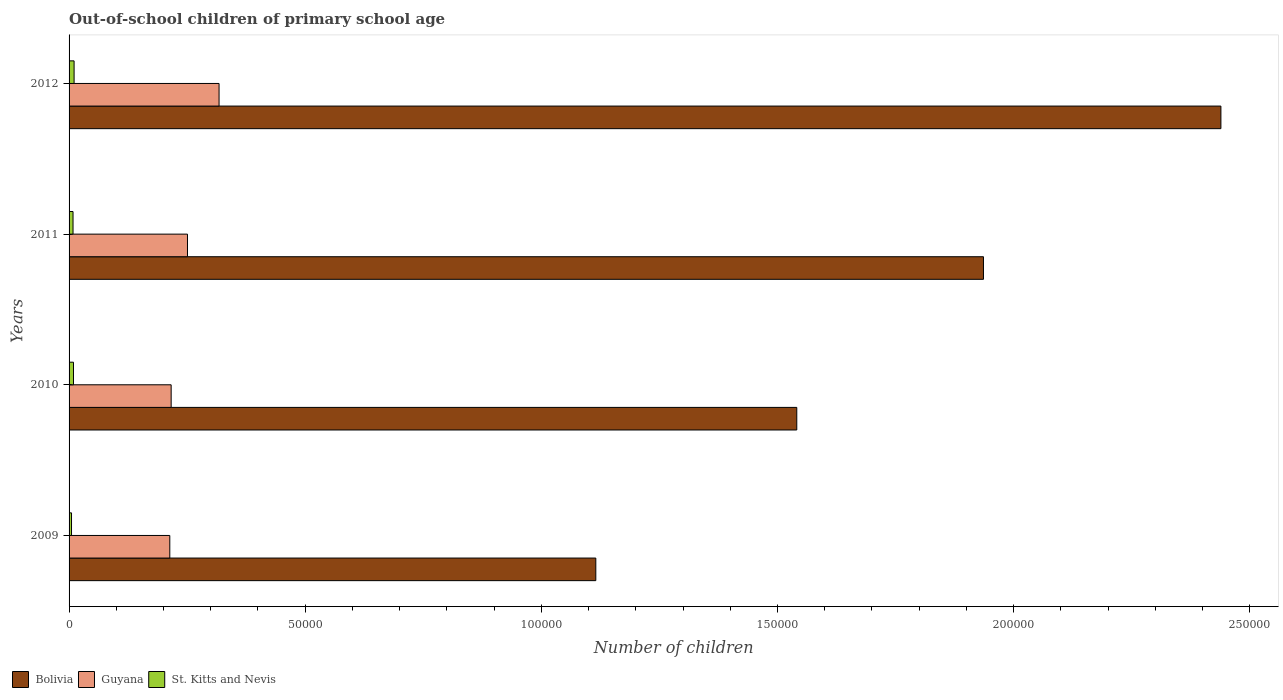How many different coloured bars are there?
Your answer should be very brief. 3. How many groups of bars are there?
Provide a short and direct response. 4. Are the number of bars per tick equal to the number of legend labels?
Your answer should be very brief. Yes. Are the number of bars on each tick of the Y-axis equal?
Offer a very short reply. Yes. How many bars are there on the 4th tick from the top?
Your answer should be very brief. 3. What is the number of out-of-school children in Bolivia in 2012?
Offer a very short reply. 2.44e+05. Across all years, what is the maximum number of out-of-school children in Guyana?
Give a very brief answer. 3.18e+04. Across all years, what is the minimum number of out-of-school children in Bolivia?
Your response must be concise. 1.12e+05. In which year was the number of out-of-school children in Guyana maximum?
Provide a short and direct response. 2012. In which year was the number of out-of-school children in Bolivia minimum?
Keep it short and to the point. 2009. What is the total number of out-of-school children in St. Kitts and Nevis in the graph?
Keep it short and to the point. 3354. What is the difference between the number of out-of-school children in Bolivia in 2011 and that in 2012?
Your answer should be compact. -5.03e+04. What is the difference between the number of out-of-school children in Bolivia in 2010 and the number of out-of-school children in St. Kitts and Nevis in 2009?
Your answer should be compact. 1.54e+05. What is the average number of out-of-school children in St. Kitts and Nevis per year?
Your response must be concise. 838.5. In the year 2011, what is the difference between the number of out-of-school children in Guyana and number of out-of-school children in St. Kitts and Nevis?
Offer a very short reply. 2.42e+04. What is the ratio of the number of out-of-school children in St. Kitts and Nevis in 2009 to that in 2012?
Your answer should be compact. 0.49. Is the number of out-of-school children in Guyana in 2009 less than that in 2011?
Ensure brevity in your answer.  Yes. Is the difference between the number of out-of-school children in Guyana in 2010 and 2011 greater than the difference between the number of out-of-school children in St. Kitts and Nevis in 2010 and 2011?
Make the answer very short. No. What is the difference between the highest and the second highest number of out-of-school children in Bolivia?
Your answer should be compact. 5.03e+04. What is the difference between the highest and the lowest number of out-of-school children in Bolivia?
Provide a short and direct response. 1.32e+05. Is the sum of the number of out-of-school children in Bolivia in 2010 and 2011 greater than the maximum number of out-of-school children in Guyana across all years?
Ensure brevity in your answer.  Yes. What does the 3rd bar from the top in 2010 represents?
Provide a succinct answer. Bolivia. What does the 2nd bar from the bottom in 2011 represents?
Keep it short and to the point. Guyana. How many bars are there?
Provide a short and direct response. 12. How many years are there in the graph?
Ensure brevity in your answer.  4. Does the graph contain any zero values?
Keep it short and to the point. No. How many legend labels are there?
Your answer should be compact. 3. What is the title of the graph?
Provide a short and direct response. Out-of-school children of primary school age. Does "Papua New Guinea" appear as one of the legend labels in the graph?
Keep it short and to the point. No. What is the label or title of the X-axis?
Offer a very short reply. Number of children. What is the Number of children of Bolivia in 2009?
Your answer should be very brief. 1.12e+05. What is the Number of children of Guyana in 2009?
Your response must be concise. 2.13e+04. What is the Number of children of St. Kitts and Nevis in 2009?
Offer a very short reply. 518. What is the Number of children in Bolivia in 2010?
Keep it short and to the point. 1.54e+05. What is the Number of children of Guyana in 2010?
Provide a succinct answer. 2.16e+04. What is the Number of children in St. Kitts and Nevis in 2010?
Keep it short and to the point. 936. What is the Number of children in Bolivia in 2011?
Offer a terse response. 1.94e+05. What is the Number of children of Guyana in 2011?
Offer a terse response. 2.51e+04. What is the Number of children in St. Kitts and Nevis in 2011?
Give a very brief answer. 838. What is the Number of children in Bolivia in 2012?
Provide a succinct answer. 2.44e+05. What is the Number of children in Guyana in 2012?
Provide a succinct answer. 3.18e+04. What is the Number of children in St. Kitts and Nevis in 2012?
Offer a terse response. 1062. Across all years, what is the maximum Number of children in Bolivia?
Your answer should be compact. 2.44e+05. Across all years, what is the maximum Number of children in Guyana?
Your response must be concise. 3.18e+04. Across all years, what is the maximum Number of children of St. Kitts and Nevis?
Ensure brevity in your answer.  1062. Across all years, what is the minimum Number of children of Bolivia?
Offer a terse response. 1.12e+05. Across all years, what is the minimum Number of children of Guyana?
Ensure brevity in your answer.  2.13e+04. Across all years, what is the minimum Number of children in St. Kitts and Nevis?
Offer a terse response. 518. What is the total Number of children in Bolivia in the graph?
Offer a very short reply. 7.03e+05. What is the total Number of children of Guyana in the graph?
Your answer should be compact. 9.98e+04. What is the total Number of children in St. Kitts and Nevis in the graph?
Your answer should be very brief. 3354. What is the difference between the Number of children in Bolivia in 2009 and that in 2010?
Provide a short and direct response. -4.26e+04. What is the difference between the Number of children in Guyana in 2009 and that in 2010?
Your response must be concise. -288. What is the difference between the Number of children in St. Kitts and Nevis in 2009 and that in 2010?
Your response must be concise. -418. What is the difference between the Number of children in Bolivia in 2009 and that in 2011?
Offer a terse response. -8.21e+04. What is the difference between the Number of children in Guyana in 2009 and that in 2011?
Provide a succinct answer. -3745. What is the difference between the Number of children in St. Kitts and Nevis in 2009 and that in 2011?
Offer a very short reply. -320. What is the difference between the Number of children in Bolivia in 2009 and that in 2012?
Your answer should be compact. -1.32e+05. What is the difference between the Number of children in Guyana in 2009 and that in 2012?
Provide a succinct answer. -1.04e+04. What is the difference between the Number of children in St. Kitts and Nevis in 2009 and that in 2012?
Ensure brevity in your answer.  -544. What is the difference between the Number of children in Bolivia in 2010 and that in 2011?
Make the answer very short. -3.95e+04. What is the difference between the Number of children of Guyana in 2010 and that in 2011?
Provide a short and direct response. -3457. What is the difference between the Number of children of Bolivia in 2010 and that in 2012?
Keep it short and to the point. -8.98e+04. What is the difference between the Number of children in Guyana in 2010 and that in 2012?
Offer a very short reply. -1.01e+04. What is the difference between the Number of children in St. Kitts and Nevis in 2010 and that in 2012?
Your answer should be very brief. -126. What is the difference between the Number of children in Bolivia in 2011 and that in 2012?
Your answer should be very brief. -5.03e+04. What is the difference between the Number of children in Guyana in 2011 and that in 2012?
Provide a short and direct response. -6688. What is the difference between the Number of children in St. Kitts and Nevis in 2011 and that in 2012?
Provide a succinct answer. -224. What is the difference between the Number of children of Bolivia in 2009 and the Number of children of Guyana in 2010?
Offer a very short reply. 8.99e+04. What is the difference between the Number of children of Bolivia in 2009 and the Number of children of St. Kitts and Nevis in 2010?
Give a very brief answer. 1.11e+05. What is the difference between the Number of children in Guyana in 2009 and the Number of children in St. Kitts and Nevis in 2010?
Make the answer very short. 2.04e+04. What is the difference between the Number of children in Bolivia in 2009 and the Number of children in Guyana in 2011?
Provide a short and direct response. 8.65e+04. What is the difference between the Number of children in Bolivia in 2009 and the Number of children in St. Kitts and Nevis in 2011?
Provide a succinct answer. 1.11e+05. What is the difference between the Number of children of Guyana in 2009 and the Number of children of St. Kitts and Nevis in 2011?
Your response must be concise. 2.05e+04. What is the difference between the Number of children of Bolivia in 2009 and the Number of children of Guyana in 2012?
Your answer should be very brief. 7.98e+04. What is the difference between the Number of children in Bolivia in 2009 and the Number of children in St. Kitts and Nevis in 2012?
Your response must be concise. 1.10e+05. What is the difference between the Number of children in Guyana in 2009 and the Number of children in St. Kitts and Nevis in 2012?
Provide a succinct answer. 2.03e+04. What is the difference between the Number of children of Bolivia in 2010 and the Number of children of Guyana in 2011?
Your answer should be very brief. 1.29e+05. What is the difference between the Number of children in Bolivia in 2010 and the Number of children in St. Kitts and Nevis in 2011?
Keep it short and to the point. 1.53e+05. What is the difference between the Number of children of Guyana in 2010 and the Number of children of St. Kitts and Nevis in 2011?
Keep it short and to the point. 2.08e+04. What is the difference between the Number of children of Bolivia in 2010 and the Number of children of Guyana in 2012?
Your answer should be very brief. 1.22e+05. What is the difference between the Number of children in Bolivia in 2010 and the Number of children in St. Kitts and Nevis in 2012?
Your answer should be compact. 1.53e+05. What is the difference between the Number of children of Guyana in 2010 and the Number of children of St. Kitts and Nevis in 2012?
Keep it short and to the point. 2.06e+04. What is the difference between the Number of children in Bolivia in 2011 and the Number of children in Guyana in 2012?
Give a very brief answer. 1.62e+05. What is the difference between the Number of children of Bolivia in 2011 and the Number of children of St. Kitts and Nevis in 2012?
Give a very brief answer. 1.93e+05. What is the difference between the Number of children of Guyana in 2011 and the Number of children of St. Kitts and Nevis in 2012?
Provide a short and direct response. 2.40e+04. What is the average Number of children of Bolivia per year?
Offer a very short reply. 1.76e+05. What is the average Number of children of Guyana per year?
Offer a very short reply. 2.49e+04. What is the average Number of children of St. Kitts and Nevis per year?
Keep it short and to the point. 838.5. In the year 2009, what is the difference between the Number of children in Bolivia and Number of children in Guyana?
Your response must be concise. 9.02e+04. In the year 2009, what is the difference between the Number of children in Bolivia and Number of children in St. Kitts and Nevis?
Offer a terse response. 1.11e+05. In the year 2009, what is the difference between the Number of children of Guyana and Number of children of St. Kitts and Nevis?
Your answer should be compact. 2.08e+04. In the year 2010, what is the difference between the Number of children of Bolivia and Number of children of Guyana?
Keep it short and to the point. 1.32e+05. In the year 2010, what is the difference between the Number of children of Bolivia and Number of children of St. Kitts and Nevis?
Provide a short and direct response. 1.53e+05. In the year 2010, what is the difference between the Number of children of Guyana and Number of children of St. Kitts and Nevis?
Your answer should be compact. 2.07e+04. In the year 2011, what is the difference between the Number of children in Bolivia and Number of children in Guyana?
Your response must be concise. 1.69e+05. In the year 2011, what is the difference between the Number of children of Bolivia and Number of children of St. Kitts and Nevis?
Offer a terse response. 1.93e+05. In the year 2011, what is the difference between the Number of children in Guyana and Number of children in St. Kitts and Nevis?
Your answer should be very brief. 2.42e+04. In the year 2012, what is the difference between the Number of children of Bolivia and Number of children of Guyana?
Ensure brevity in your answer.  2.12e+05. In the year 2012, what is the difference between the Number of children in Bolivia and Number of children in St. Kitts and Nevis?
Provide a short and direct response. 2.43e+05. In the year 2012, what is the difference between the Number of children of Guyana and Number of children of St. Kitts and Nevis?
Your answer should be very brief. 3.07e+04. What is the ratio of the Number of children in Bolivia in 2009 to that in 2010?
Provide a succinct answer. 0.72. What is the ratio of the Number of children in Guyana in 2009 to that in 2010?
Keep it short and to the point. 0.99. What is the ratio of the Number of children of St. Kitts and Nevis in 2009 to that in 2010?
Your answer should be very brief. 0.55. What is the ratio of the Number of children of Bolivia in 2009 to that in 2011?
Offer a very short reply. 0.58. What is the ratio of the Number of children in Guyana in 2009 to that in 2011?
Your response must be concise. 0.85. What is the ratio of the Number of children in St. Kitts and Nevis in 2009 to that in 2011?
Ensure brevity in your answer.  0.62. What is the ratio of the Number of children of Bolivia in 2009 to that in 2012?
Your answer should be compact. 0.46. What is the ratio of the Number of children in Guyana in 2009 to that in 2012?
Make the answer very short. 0.67. What is the ratio of the Number of children in St. Kitts and Nevis in 2009 to that in 2012?
Keep it short and to the point. 0.49. What is the ratio of the Number of children in Bolivia in 2010 to that in 2011?
Provide a succinct answer. 0.8. What is the ratio of the Number of children in Guyana in 2010 to that in 2011?
Give a very brief answer. 0.86. What is the ratio of the Number of children of St. Kitts and Nevis in 2010 to that in 2011?
Your answer should be very brief. 1.12. What is the ratio of the Number of children in Bolivia in 2010 to that in 2012?
Offer a terse response. 0.63. What is the ratio of the Number of children of Guyana in 2010 to that in 2012?
Ensure brevity in your answer.  0.68. What is the ratio of the Number of children of St. Kitts and Nevis in 2010 to that in 2012?
Your answer should be very brief. 0.88. What is the ratio of the Number of children of Bolivia in 2011 to that in 2012?
Your response must be concise. 0.79. What is the ratio of the Number of children in Guyana in 2011 to that in 2012?
Ensure brevity in your answer.  0.79. What is the ratio of the Number of children in St. Kitts and Nevis in 2011 to that in 2012?
Offer a very short reply. 0.79. What is the difference between the highest and the second highest Number of children of Bolivia?
Your answer should be compact. 5.03e+04. What is the difference between the highest and the second highest Number of children in Guyana?
Provide a short and direct response. 6688. What is the difference between the highest and the second highest Number of children in St. Kitts and Nevis?
Provide a succinct answer. 126. What is the difference between the highest and the lowest Number of children in Bolivia?
Make the answer very short. 1.32e+05. What is the difference between the highest and the lowest Number of children in Guyana?
Offer a very short reply. 1.04e+04. What is the difference between the highest and the lowest Number of children in St. Kitts and Nevis?
Give a very brief answer. 544. 